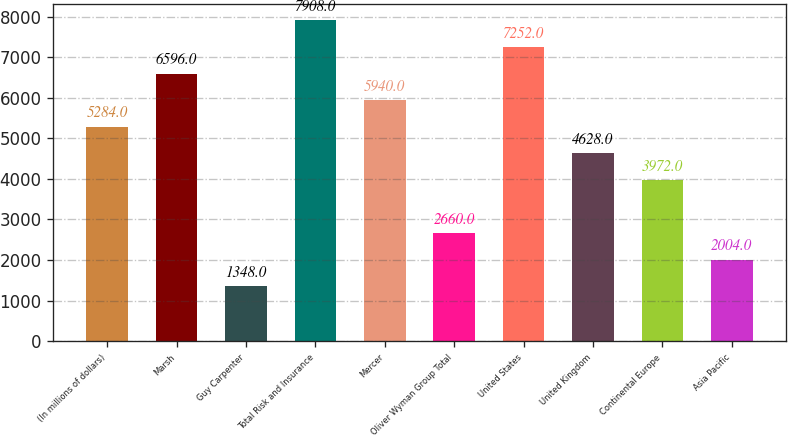Convert chart to OTSL. <chart><loc_0><loc_0><loc_500><loc_500><bar_chart><fcel>(In millions of dollars)<fcel>Marsh<fcel>Guy Carpenter<fcel>Total Risk and Insurance<fcel>Mercer<fcel>Oliver Wyman Group Total<fcel>United States<fcel>United Kingdom<fcel>Continental Europe<fcel>Asia Pacific<nl><fcel>5284<fcel>6596<fcel>1348<fcel>7908<fcel>5940<fcel>2660<fcel>7252<fcel>4628<fcel>3972<fcel>2004<nl></chart> 